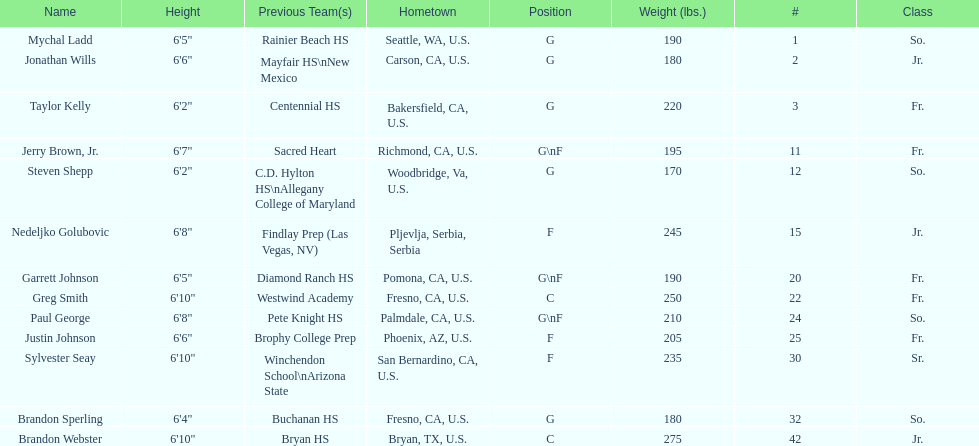How many players hometowns are outside of california? 5. 